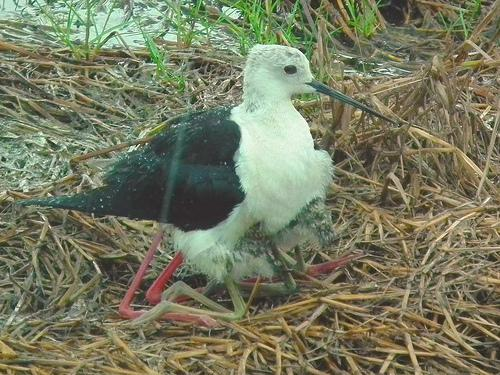Question: what color is the bird's body?
Choices:
A. Blue and black.
B. Red and white.
C. Black and white.
D. White and grey.
Answer with the letter. Answer: C Question: how many of the bird's eyes are visible?
Choices:
A. None.
B. Two.
C. Three.
D. One.
Answer with the letter. Answer: D 